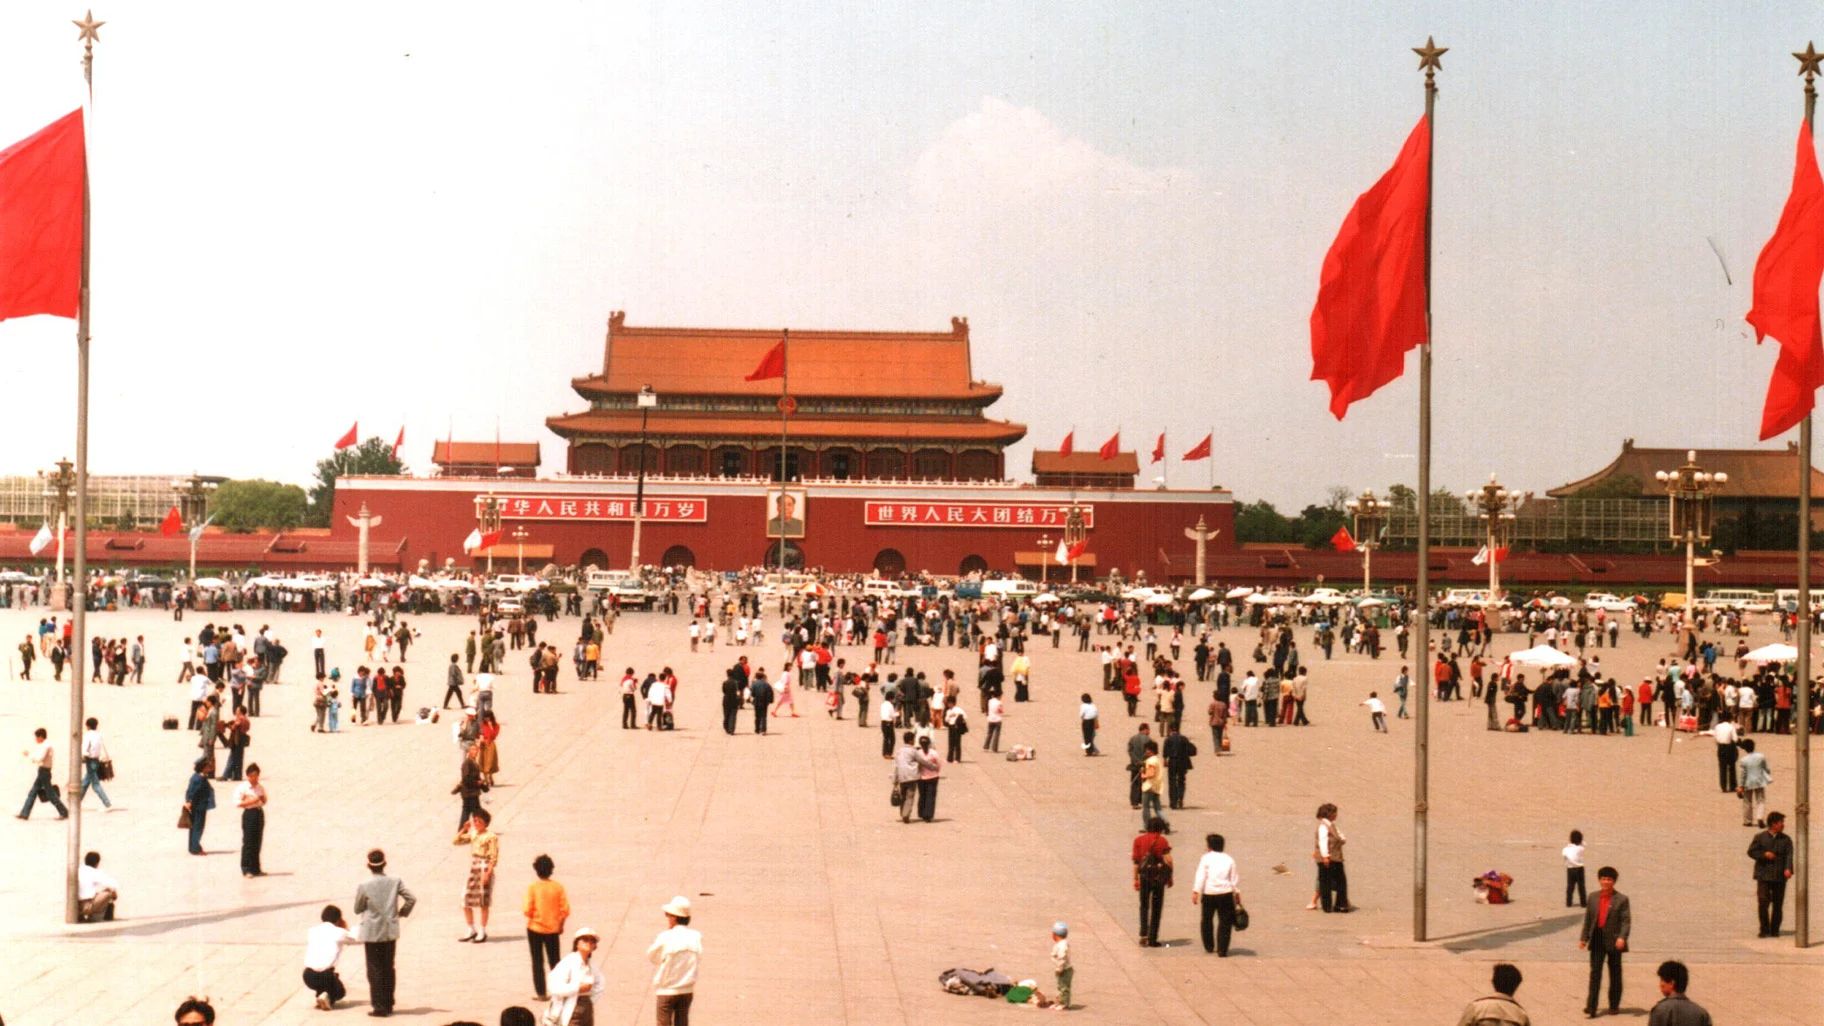Create a fictional scenario where the square becomes a stage for an international festival of lights. In this enchanting fictional scenario, Tiananmen Square transforms into a dazzling stage for an International Festival of Lights. As dusk falls, the square glows with the radiance of millions of lights, each display representing the culture and creativity of different countries. Lanterns of all shapes and sizes float in the air, while light sculptures and interactive installations turn the square into a visually captivating wonderland. Projections on the historic Tiananmen building tell stories from around the globe, merging traditional Chinese elements with modern digital art. People from diverse backgrounds gather, their faces illuminated by the vibrant array of colors. Music from various cultures creates a harmonious soundscape, adding to the festive atmosphere. The night culminates in a grand light show, where synchronized displays of lasers and fireworks light up the sky, celebrating unity and the shared experience of human creativity and innovation. 